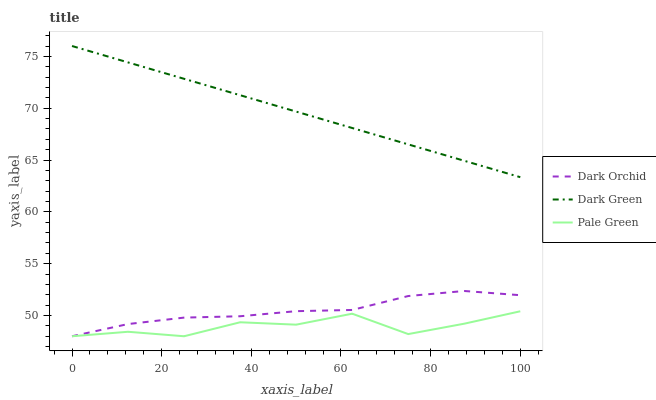Does Pale Green have the minimum area under the curve?
Answer yes or no. Yes. Does Dark Green have the maximum area under the curve?
Answer yes or no. Yes. Does Dark Orchid have the minimum area under the curve?
Answer yes or no. No. Does Dark Orchid have the maximum area under the curve?
Answer yes or no. No. Is Dark Green the smoothest?
Answer yes or no. Yes. Is Pale Green the roughest?
Answer yes or no. Yes. Is Dark Orchid the smoothest?
Answer yes or no. No. Is Dark Orchid the roughest?
Answer yes or no. No. Does Pale Green have the lowest value?
Answer yes or no. Yes. Does Dark Green have the lowest value?
Answer yes or no. No. Does Dark Green have the highest value?
Answer yes or no. Yes. Does Dark Orchid have the highest value?
Answer yes or no. No. Is Pale Green less than Dark Green?
Answer yes or no. Yes. Is Dark Green greater than Dark Orchid?
Answer yes or no. Yes. Does Dark Orchid intersect Pale Green?
Answer yes or no. Yes. Is Dark Orchid less than Pale Green?
Answer yes or no. No. Is Dark Orchid greater than Pale Green?
Answer yes or no. No. Does Pale Green intersect Dark Green?
Answer yes or no. No. 